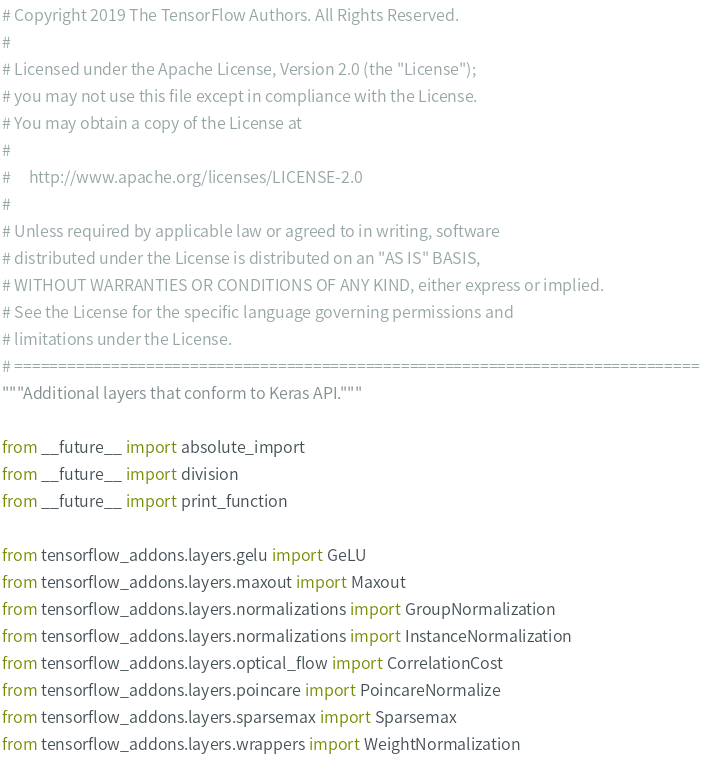<code> <loc_0><loc_0><loc_500><loc_500><_Python_># Copyright 2019 The TensorFlow Authors. All Rights Reserved.
#
# Licensed under the Apache License, Version 2.0 (the "License");
# you may not use this file except in compliance with the License.
# You may obtain a copy of the License at
#
#     http://www.apache.org/licenses/LICENSE-2.0
#
# Unless required by applicable law or agreed to in writing, software
# distributed under the License is distributed on an "AS IS" BASIS,
# WITHOUT WARRANTIES OR CONDITIONS OF ANY KIND, either express or implied.
# See the License for the specific language governing permissions and
# limitations under the License.
# ==============================================================================
"""Additional layers that conform to Keras API."""

from __future__ import absolute_import
from __future__ import division
from __future__ import print_function

from tensorflow_addons.layers.gelu import GeLU
from tensorflow_addons.layers.maxout import Maxout
from tensorflow_addons.layers.normalizations import GroupNormalization
from tensorflow_addons.layers.normalizations import InstanceNormalization
from tensorflow_addons.layers.optical_flow import CorrelationCost
from tensorflow_addons.layers.poincare import PoincareNormalize
from tensorflow_addons.layers.sparsemax import Sparsemax
from tensorflow_addons.layers.wrappers import WeightNormalization</code> 